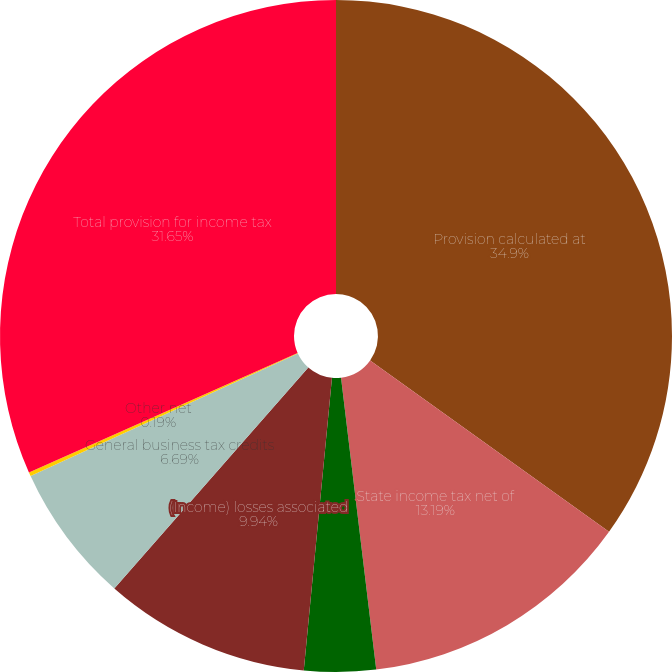<chart> <loc_0><loc_0><loc_500><loc_500><pie_chart><fcel>Provision calculated at<fcel>State income tax net of<fcel>Tax-exempt interest income<fcel>(Income) losses associated<fcel>General business tax credits<fcel>Other net<fcel>Total provision for income tax<nl><fcel>34.91%<fcel>13.19%<fcel>3.44%<fcel>9.94%<fcel>6.69%<fcel>0.19%<fcel>31.66%<nl></chart> 